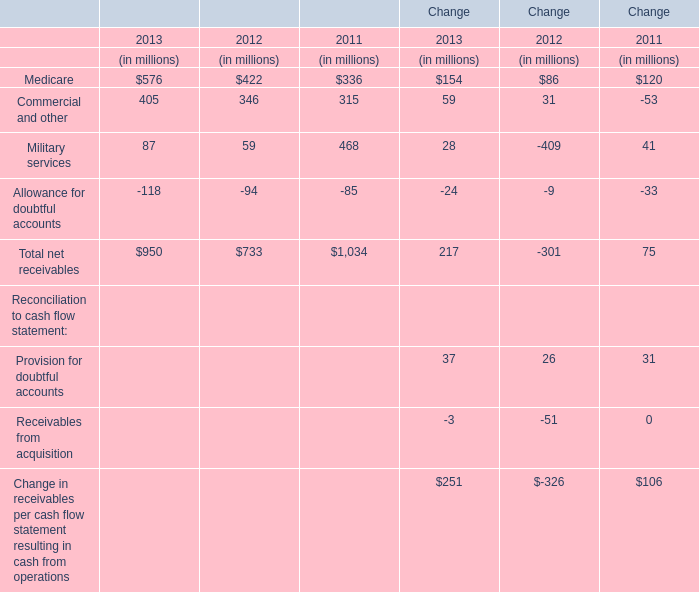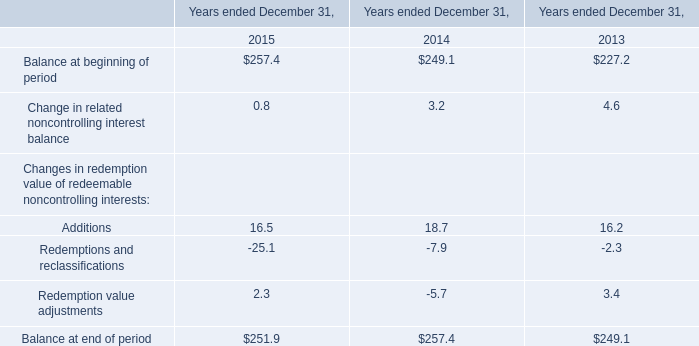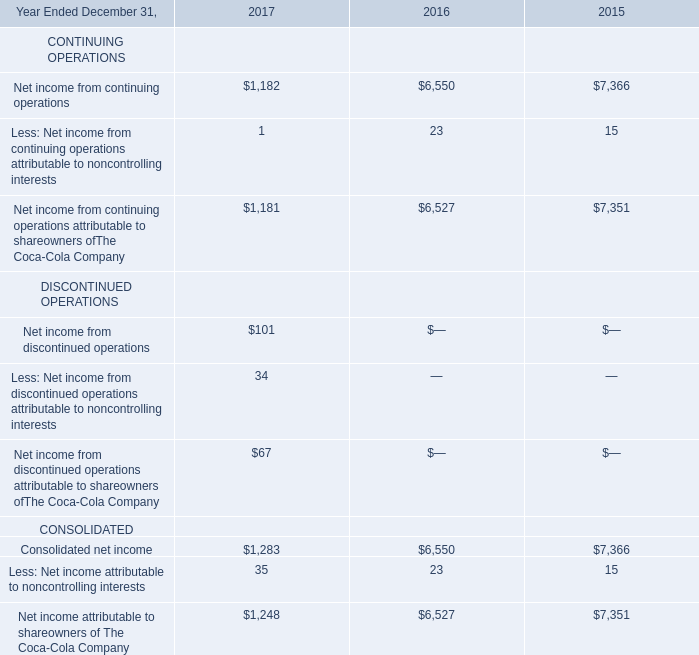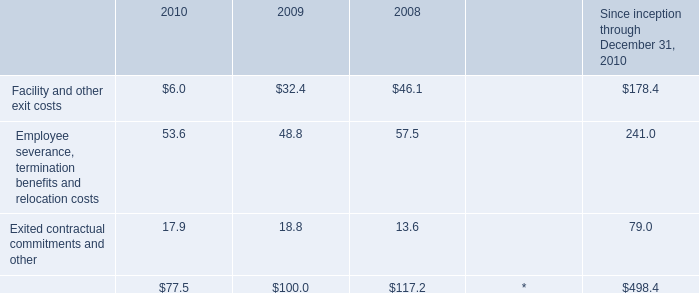What is the sum of Medicare, Commercial and other and Military services in 2013 ? (in million) 
Computations: ((576 + 405) + 87)
Answer: 1068.0. 